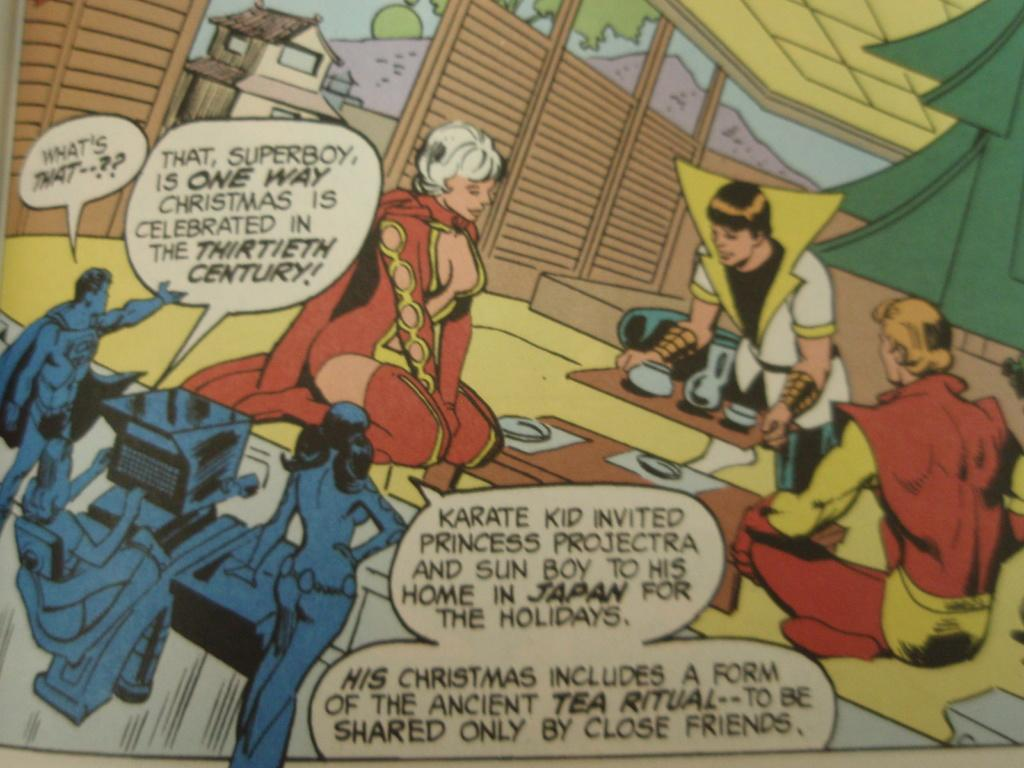<image>
Describe the image concisely. A comic has the character Superboy in it. 